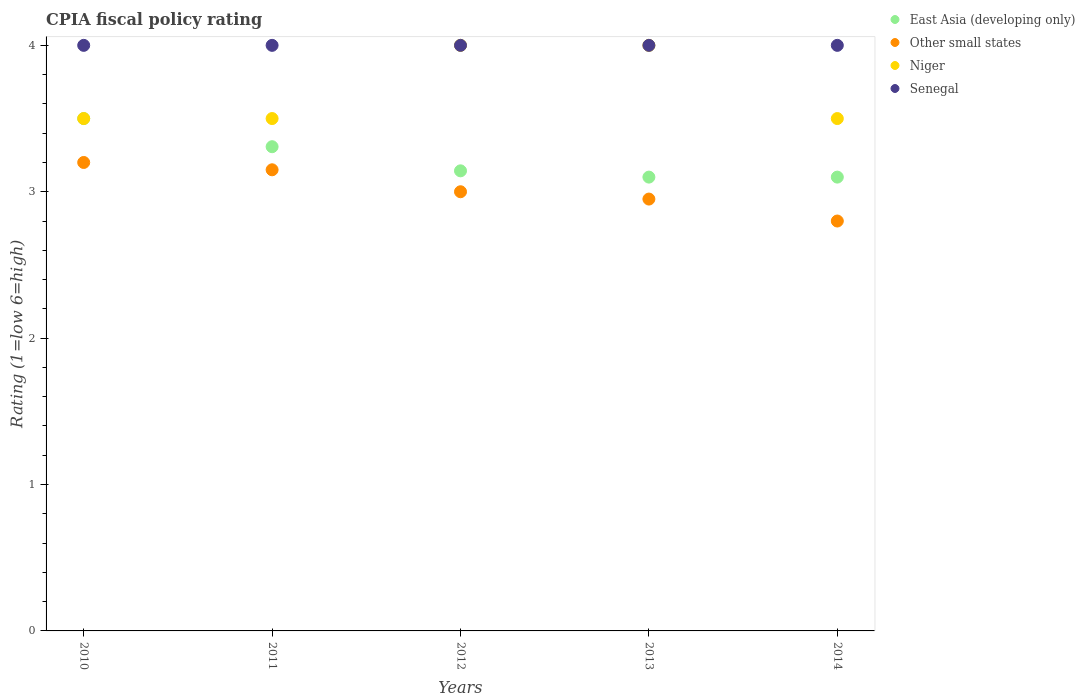Is the number of dotlines equal to the number of legend labels?
Offer a very short reply. Yes. Across all years, what is the maximum CPIA rating in Niger?
Offer a very short reply. 4. Across all years, what is the minimum CPIA rating in Other small states?
Give a very brief answer. 2.8. In which year was the CPIA rating in Niger maximum?
Ensure brevity in your answer.  2012. In which year was the CPIA rating in Other small states minimum?
Your answer should be very brief. 2014. What is the total CPIA rating in East Asia (developing only) in the graph?
Your response must be concise. 16.15. What is the difference between the CPIA rating in East Asia (developing only) in 2011 and that in 2014?
Ensure brevity in your answer.  0.21. What is the difference between the CPIA rating in Niger in 2014 and the CPIA rating in East Asia (developing only) in 2012?
Offer a terse response. 0.36. What is the average CPIA rating in East Asia (developing only) per year?
Your response must be concise. 3.23. What is the difference between the highest and the second highest CPIA rating in Senegal?
Keep it short and to the point. 0. What is the difference between the highest and the lowest CPIA rating in Senegal?
Your answer should be very brief. 0. In how many years, is the CPIA rating in Niger greater than the average CPIA rating in Niger taken over all years?
Provide a short and direct response. 2. Is it the case that in every year, the sum of the CPIA rating in Other small states and CPIA rating in Senegal  is greater than the CPIA rating in Niger?
Give a very brief answer. Yes. Does the CPIA rating in Niger monotonically increase over the years?
Provide a short and direct response. No. How many dotlines are there?
Your answer should be very brief. 4. What is the difference between two consecutive major ticks on the Y-axis?
Keep it short and to the point. 1. Does the graph contain grids?
Offer a terse response. No. How are the legend labels stacked?
Make the answer very short. Vertical. What is the title of the graph?
Provide a short and direct response. CPIA fiscal policy rating. Does "Europe(all income levels)" appear as one of the legend labels in the graph?
Your answer should be very brief. No. What is the label or title of the X-axis?
Make the answer very short. Years. What is the label or title of the Y-axis?
Your response must be concise. Rating (1=low 6=high). What is the Rating (1=low 6=high) in Senegal in 2010?
Provide a short and direct response. 4. What is the Rating (1=low 6=high) in East Asia (developing only) in 2011?
Make the answer very short. 3.31. What is the Rating (1=low 6=high) in Other small states in 2011?
Your answer should be compact. 3.15. What is the Rating (1=low 6=high) of Niger in 2011?
Keep it short and to the point. 3.5. What is the Rating (1=low 6=high) of Senegal in 2011?
Offer a terse response. 4. What is the Rating (1=low 6=high) in East Asia (developing only) in 2012?
Give a very brief answer. 3.14. What is the Rating (1=low 6=high) in Niger in 2012?
Provide a succinct answer. 4. What is the Rating (1=low 6=high) in Other small states in 2013?
Offer a very short reply. 2.95. What is the Rating (1=low 6=high) in Niger in 2013?
Your answer should be very brief. 4. What is the Rating (1=low 6=high) of Senegal in 2013?
Keep it short and to the point. 4. What is the Rating (1=low 6=high) in Other small states in 2014?
Provide a short and direct response. 2.8. What is the Rating (1=low 6=high) in Senegal in 2014?
Provide a succinct answer. 4. Across all years, what is the maximum Rating (1=low 6=high) in Other small states?
Provide a succinct answer. 3.2. Across all years, what is the minimum Rating (1=low 6=high) in East Asia (developing only)?
Ensure brevity in your answer.  3.1. Across all years, what is the minimum Rating (1=low 6=high) in Senegal?
Offer a very short reply. 4. What is the total Rating (1=low 6=high) in East Asia (developing only) in the graph?
Make the answer very short. 16.15. What is the total Rating (1=low 6=high) in Other small states in the graph?
Provide a short and direct response. 15.1. What is the difference between the Rating (1=low 6=high) in East Asia (developing only) in 2010 and that in 2011?
Provide a short and direct response. 0.19. What is the difference between the Rating (1=low 6=high) of Senegal in 2010 and that in 2011?
Provide a succinct answer. 0. What is the difference between the Rating (1=low 6=high) of East Asia (developing only) in 2010 and that in 2012?
Give a very brief answer. 0.36. What is the difference between the Rating (1=low 6=high) of Niger in 2010 and that in 2012?
Keep it short and to the point. -0.5. What is the difference between the Rating (1=low 6=high) of Other small states in 2010 and that in 2013?
Keep it short and to the point. 0.25. What is the difference between the Rating (1=low 6=high) in Niger in 2010 and that in 2013?
Offer a terse response. -0.5. What is the difference between the Rating (1=low 6=high) in Niger in 2010 and that in 2014?
Provide a short and direct response. 0. What is the difference between the Rating (1=low 6=high) of Senegal in 2010 and that in 2014?
Provide a succinct answer. 0. What is the difference between the Rating (1=low 6=high) of East Asia (developing only) in 2011 and that in 2012?
Give a very brief answer. 0.16. What is the difference between the Rating (1=low 6=high) in Other small states in 2011 and that in 2012?
Give a very brief answer. 0.15. What is the difference between the Rating (1=low 6=high) in Niger in 2011 and that in 2012?
Give a very brief answer. -0.5. What is the difference between the Rating (1=low 6=high) in Senegal in 2011 and that in 2012?
Offer a very short reply. 0. What is the difference between the Rating (1=low 6=high) of East Asia (developing only) in 2011 and that in 2013?
Your response must be concise. 0.21. What is the difference between the Rating (1=low 6=high) in Other small states in 2011 and that in 2013?
Your answer should be compact. 0.2. What is the difference between the Rating (1=low 6=high) of Senegal in 2011 and that in 2013?
Provide a short and direct response. 0. What is the difference between the Rating (1=low 6=high) of East Asia (developing only) in 2011 and that in 2014?
Ensure brevity in your answer.  0.21. What is the difference between the Rating (1=low 6=high) in Other small states in 2011 and that in 2014?
Your answer should be compact. 0.35. What is the difference between the Rating (1=low 6=high) of East Asia (developing only) in 2012 and that in 2013?
Ensure brevity in your answer.  0.04. What is the difference between the Rating (1=low 6=high) of Senegal in 2012 and that in 2013?
Ensure brevity in your answer.  0. What is the difference between the Rating (1=low 6=high) in East Asia (developing only) in 2012 and that in 2014?
Provide a short and direct response. 0.04. What is the difference between the Rating (1=low 6=high) in Other small states in 2012 and that in 2014?
Ensure brevity in your answer.  0.2. What is the difference between the Rating (1=low 6=high) of Niger in 2012 and that in 2014?
Offer a terse response. 0.5. What is the difference between the Rating (1=low 6=high) of East Asia (developing only) in 2013 and that in 2014?
Your answer should be compact. 0. What is the difference between the Rating (1=low 6=high) of East Asia (developing only) in 2010 and the Rating (1=low 6=high) of Niger in 2011?
Make the answer very short. 0. What is the difference between the Rating (1=low 6=high) in Other small states in 2010 and the Rating (1=low 6=high) in Senegal in 2011?
Offer a very short reply. -0.8. What is the difference between the Rating (1=low 6=high) of East Asia (developing only) in 2010 and the Rating (1=low 6=high) of Other small states in 2012?
Your answer should be very brief. 0.5. What is the difference between the Rating (1=low 6=high) of East Asia (developing only) in 2010 and the Rating (1=low 6=high) of Niger in 2012?
Make the answer very short. -0.5. What is the difference between the Rating (1=low 6=high) in East Asia (developing only) in 2010 and the Rating (1=low 6=high) in Senegal in 2012?
Your answer should be very brief. -0.5. What is the difference between the Rating (1=low 6=high) of Other small states in 2010 and the Rating (1=low 6=high) of Niger in 2012?
Provide a short and direct response. -0.8. What is the difference between the Rating (1=low 6=high) of Niger in 2010 and the Rating (1=low 6=high) of Senegal in 2012?
Keep it short and to the point. -0.5. What is the difference between the Rating (1=low 6=high) of East Asia (developing only) in 2010 and the Rating (1=low 6=high) of Other small states in 2013?
Give a very brief answer. 0.55. What is the difference between the Rating (1=low 6=high) in East Asia (developing only) in 2010 and the Rating (1=low 6=high) in Niger in 2013?
Offer a very short reply. -0.5. What is the difference between the Rating (1=low 6=high) of East Asia (developing only) in 2010 and the Rating (1=low 6=high) of Senegal in 2013?
Give a very brief answer. -0.5. What is the difference between the Rating (1=low 6=high) in Niger in 2010 and the Rating (1=low 6=high) in Senegal in 2013?
Offer a very short reply. -0.5. What is the difference between the Rating (1=low 6=high) in East Asia (developing only) in 2010 and the Rating (1=low 6=high) in Other small states in 2014?
Your answer should be compact. 0.7. What is the difference between the Rating (1=low 6=high) in East Asia (developing only) in 2010 and the Rating (1=low 6=high) in Niger in 2014?
Your response must be concise. 0. What is the difference between the Rating (1=low 6=high) in East Asia (developing only) in 2010 and the Rating (1=low 6=high) in Senegal in 2014?
Provide a succinct answer. -0.5. What is the difference between the Rating (1=low 6=high) in Other small states in 2010 and the Rating (1=low 6=high) in Niger in 2014?
Your response must be concise. -0.3. What is the difference between the Rating (1=low 6=high) in Other small states in 2010 and the Rating (1=low 6=high) in Senegal in 2014?
Your response must be concise. -0.8. What is the difference between the Rating (1=low 6=high) in East Asia (developing only) in 2011 and the Rating (1=low 6=high) in Other small states in 2012?
Make the answer very short. 0.31. What is the difference between the Rating (1=low 6=high) in East Asia (developing only) in 2011 and the Rating (1=low 6=high) in Niger in 2012?
Provide a short and direct response. -0.69. What is the difference between the Rating (1=low 6=high) of East Asia (developing only) in 2011 and the Rating (1=low 6=high) of Senegal in 2012?
Offer a very short reply. -0.69. What is the difference between the Rating (1=low 6=high) in Other small states in 2011 and the Rating (1=low 6=high) in Niger in 2012?
Provide a short and direct response. -0.85. What is the difference between the Rating (1=low 6=high) of Other small states in 2011 and the Rating (1=low 6=high) of Senegal in 2012?
Give a very brief answer. -0.85. What is the difference between the Rating (1=low 6=high) of Niger in 2011 and the Rating (1=low 6=high) of Senegal in 2012?
Your answer should be very brief. -0.5. What is the difference between the Rating (1=low 6=high) in East Asia (developing only) in 2011 and the Rating (1=low 6=high) in Other small states in 2013?
Offer a terse response. 0.36. What is the difference between the Rating (1=low 6=high) in East Asia (developing only) in 2011 and the Rating (1=low 6=high) in Niger in 2013?
Give a very brief answer. -0.69. What is the difference between the Rating (1=low 6=high) of East Asia (developing only) in 2011 and the Rating (1=low 6=high) of Senegal in 2013?
Give a very brief answer. -0.69. What is the difference between the Rating (1=low 6=high) of Other small states in 2011 and the Rating (1=low 6=high) of Niger in 2013?
Give a very brief answer. -0.85. What is the difference between the Rating (1=low 6=high) in Other small states in 2011 and the Rating (1=low 6=high) in Senegal in 2013?
Ensure brevity in your answer.  -0.85. What is the difference between the Rating (1=low 6=high) in Niger in 2011 and the Rating (1=low 6=high) in Senegal in 2013?
Give a very brief answer. -0.5. What is the difference between the Rating (1=low 6=high) of East Asia (developing only) in 2011 and the Rating (1=low 6=high) of Other small states in 2014?
Your answer should be compact. 0.51. What is the difference between the Rating (1=low 6=high) in East Asia (developing only) in 2011 and the Rating (1=low 6=high) in Niger in 2014?
Offer a very short reply. -0.19. What is the difference between the Rating (1=low 6=high) of East Asia (developing only) in 2011 and the Rating (1=low 6=high) of Senegal in 2014?
Offer a terse response. -0.69. What is the difference between the Rating (1=low 6=high) of Other small states in 2011 and the Rating (1=low 6=high) of Niger in 2014?
Your response must be concise. -0.35. What is the difference between the Rating (1=low 6=high) in Other small states in 2011 and the Rating (1=low 6=high) in Senegal in 2014?
Make the answer very short. -0.85. What is the difference between the Rating (1=low 6=high) of Niger in 2011 and the Rating (1=low 6=high) of Senegal in 2014?
Your answer should be very brief. -0.5. What is the difference between the Rating (1=low 6=high) of East Asia (developing only) in 2012 and the Rating (1=low 6=high) of Other small states in 2013?
Make the answer very short. 0.19. What is the difference between the Rating (1=low 6=high) of East Asia (developing only) in 2012 and the Rating (1=low 6=high) of Niger in 2013?
Keep it short and to the point. -0.86. What is the difference between the Rating (1=low 6=high) in East Asia (developing only) in 2012 and the Rating (1=low 6=high) in Senegal in 2013?
Ensure brevity in your answer.  -0.86. What is the difference between the Rating (1=low 6=high) of East Asia (developing only) in 2012 and the Rating (1=low 6=high) of Other small states in 2014?
Keep it short and to the point. 0.34. What is the difference between the Rating (1=low 6=high) of East Asia (developing only) in 2012 and the Rating (1=low 6=high) of Niger in 2014?
Give a very brief answer. -0.36. What is the difference between the Rating (1=low 6=high) in East Asia (developing only) in 2012 and the Rating (1=low 6=high) in Senegal in 2014?
Ensure brevity in your answer.  -0.86. What is the difference between the Rating (1=low 6=high) of Other small states in 2012 and the Rating (1=low 6=high) of Niger in 2014?
Provide a short and direct response. -0.5. What is the difference between the Rating (1=low 6=high) of East Asia (developing only) in 2013 and the Rating (1=low 6=high) of Niger in 2014?
Offer a very short reply. -0.4. What is the difference between the Rating (1=low 6=high) in Other small states in 2013 and the Rating (1=low 6=high) in Niger in 2014?
Your answer should be very brief. -0.55. What is the difference between the Rating (1=low 6=high) in Other small states in 2013 and the Rating (1=low 6=high) in Senegal in 2014?
Ensure brevity in your answer.  -1.05. What is the difference between the Rating (1=low 6=high) in Niger in 2013 and the Rating (1=low 6=high) in Senegal in 2014?
Your answer should be very brief. 0. What is the average Rating (1=low 6=high) in East Asia (developing only) per year?
Provide a succinct answer. 3.23. What is the average Rating (1=low 6=high) in Other small states per year?
Your answer should be compact. 3.02. In the year 2010, what is the difference between the Rating (1=low 6=high) of East Asia (developing only) and Rating (1=low 6=high) of Other small states?
Ensure brevity in your answer.  0.3. In the year 2010, what is the difference between the Rating (1=low 6=high) in East Asia (developing only) and Rating (1=low 6=high) in Niger?
Offer a terse response. 0. In the year 2010, what is the difference between the Rating (1=low 6=high) of East Asia (developing only) and Rating (1=low 6=high) of Senegal?
Provide a succinct answer. -0.5. In the year 2010, what is the difference between the Rating (1=low 6=high) in Other small states and Rating (1=low 6=high) in Senegal?
Ensure brevity in your answer.  -0.8. In the year 2010, what is the difference between the Rating (1=low 6=high) in Niger and Rating (1=low 6=high) in Senegal?
Offer a very short reply. -0.5. In the year 2011, what is the difference between the Rating (1=low 6=high) of East Asia (developing only) and Rating (1=low 6=high) of Other small states?
Provide a short and direct response. 0.16. In the year 2011, what is the difference between the Rating (1=low 6=high) in East Asia (developing only) and Rating (1=low 6=high) in Niger?
Your response must be concise. -0.19. In the year 2011, what is the difference between the Rating (1=low 6=high) of East Asia (developing only) and Rating (1=low 6=high) of Senegal?
Make the answer very short. -0.69. In the year 2011, what is the difference between the Rating (1=low 6=high) in Other small states and Rating (1=low 6=high) in Niger?
Provide a short and direct response. -0.35. In the year 2011, what is the difference between the Rating (1=low 6=high) in Other small states and Rating (1=low 6=high) in Senegal?
Your response must be concise. -0.85. In the year 2011, what is the difference between the Rating (1=low 6=high) of Niger and Rating (1=low 6=high) of Senegal?
Offer a terse response. -0.5. In the year 2012, what is the difference between the Rating (1=low 6=high) of East Asia (developing only) and Rating (1=low 6=high) of Other small states?
Make the answer very short. 0.14. In the year 2012, what is the difference between the Rating (1=low 6=high) in East Asia (developing only) and Rating (1=low 6=high) in Niger?
Your response must be concise. -0.86. In the year 2012, what is the difference between the Rating (1=low 6=high) of East Asia (developing only) and Rating (1=low 6=high) of Senegal?
Make the answer very short. -0.86. In the year 2012, what is the difference between the Rating (1=low 6=high) in Other small states and Rating (1=low 6=high) in Niger?
Offer a terse response. -1. In the year 2012, what is the difference between the Rating (1=low 6=high) in Other small states and Rating (1=low 6=high) in Senegal?
Offer a very short reply. -1. In the year 2012, what is the difference between the Rating (1=low 6=high) of Niger and Rating (1=low 6=high) of Senegal?
Provide a short and direct response. 0. In the year 2013, what is the difference between the Rating (1=low 6=high) in East Asia (developing only) and Rating (1=low 6=high) in Niger?
Your answer should be very brief. -0.9. In the year 2013, what is the difference between the Rating (1=low 6=high) in East Asia (developing only) and Rating (1=low 6=high) in Senegal?
Make the answer very short. -0.9. In the year 2013, what is the difference between the Rating (1=low 6=high) in Other small states and Rating (1=low 6=high) in Niger?
Provide a short and direct response. -1.05. In the year 2013, what is the difference between the Rating (1=low 6=high) of Other small states and Rating (1=low 6=high) of Senegal?
Your answer should be very brief. -1.05. In the year 2013, what is the difference between the Rating (1=low 6=high) in Niger and Rating (1=low 6=high) in Senegal?
Provide a succinct answer. 0. In the year 2014, what is the difference between the Rating (1=low 6=high) in East Asia (developing only) and Rating (1=low 6=high) in Niger?
Your response must be concise. -0.4. What is the ratio of the Rating (1=low 6=high) in East Asia (developing only) in 2010 to that in 2011?
Your response must be concise. 1.06. What is the ratio of the Rating (1=low 6=high) in Other small states in 2010 to that in 2011?
Provide a short and direct response. 1.02. What is the ratio of the Rating (1=low 6=high) in East Asia (developing only) in 2010 to that in 2012?
Provide a succinct answer. 1.11. What is the ratio of the Rating (1=low 6=high) in Other small states in 2010 to that in 2012?
Ensure brevity in your answer.  1.07. What is the ratio of the Rating (1=low 6=high) of Senegal in 2010 to that in 2012?
Keep it short and to the point. 1. What is the ratio of the Rating (1=low 6=high) of East Asia (developing only) in 2010 to that in 2013?
Your answer should be compact. 1.13. What is the ratio of the Rating (1=low 6=high) in Other small states in 2010 to that in 2013?
Make the answer very short. 1.08. What is the ratio of the Rating (1=low 6=high) of Senegal in 2010 to that in 2013?
Offer a very short reply. 1. What is the ratio of the Rating (1=low 6=high) of East Asia (developing only) in 2010 to that in 2014?
Make the answer very short. 1.13. What is the ratio of the Rating (1=low 6=high) of Other small states in 2010 to that in 2014?
Your answer should be compact. 1.14. What is the ratio of the Rating (1=low 6=high) of East Asia (developing only) in 2011 to that in 2012?
Ensure brevity in your answer.  1.05. What is the ratio of the Rating (1=low 6=high) in Niger in 2011 to that in 2012?
Keep it short and to the point. 0.88. What is the ratio of the Rating (1=low 6=high) of East Asia (developing only) in 2011 to that in 2013?
Make the answer very short. 1.07. What is the ratio of the Rating (1=low 6=high) in Other small states in 2011 to that in 2013?
Your response must be concise. 1.07. What is the ratio of the Rating (1=low 6=high) in Senegal in 2011 to that in 2013?
Your response must be concise. 1. What is the ratio of the Rating (1=low 6=high) in East Asia (developing only) in 2011 to that in 2014?
Your response must be concise. 1.07. What is the ratio of the Rating (1=low 6=high) of Niger in 2011 to that in 2014?
Your response must be concise. 1. What is the ratio of the Rating (1=low 6=high) in East Asia (developing only) in 2012 to that in 2013?
Offer a terse response. 1.01. What is the ratio of the Rating (1=low 6=high) in Other small states in 2012 to that in 2013?
Your response must be concise. 1.02. What is the ratio of the Rating (1=low 6=high) in Niger in 2012 to that in 2013?
Offer a very short reply. 1. What is the ratio of the Rating (1=low 6=high) of East Asia (developing only) in 2012 to that in 2014?
Ensure brevity in your answer.  1.01. What is the ratio of the Rating (1=low 6=high) in Other small states in 2012 to that in 2014?
Offer a very short reply. 1.07. What is the ratio of the Rating (1=low 6=high) of East Asia (developing only) in 2013 to that in 2014?
Ensure brevity in your answer.  1. What is the ratio of the Rating (1=low 6=high) in Other small states in 2013 to that in 2014?
Give a very brief answer. 1.05. What is the difference between the highest and the second highest Rating (1=low 6=high) in East Asia (developing only)?
Your answer should be compact. 0.19. What is the difference between the highest and the second highest Rating (1=low 6=high) of Other small states?
Your response must be concise. 0.05. What is the difference between the highest and the lowest Rating (1=low 6=high) in East Asia (developing only)?
Make the answer very short. 0.4. What is the difference between the highest and the lowest Rating (1=low 6=high) in Niger?
Keep it short and to the point. 0.5. What is the difference between the highest and the lowest Rating (1=low 6=high) in Senegal?
Offer a terse response. 0. 